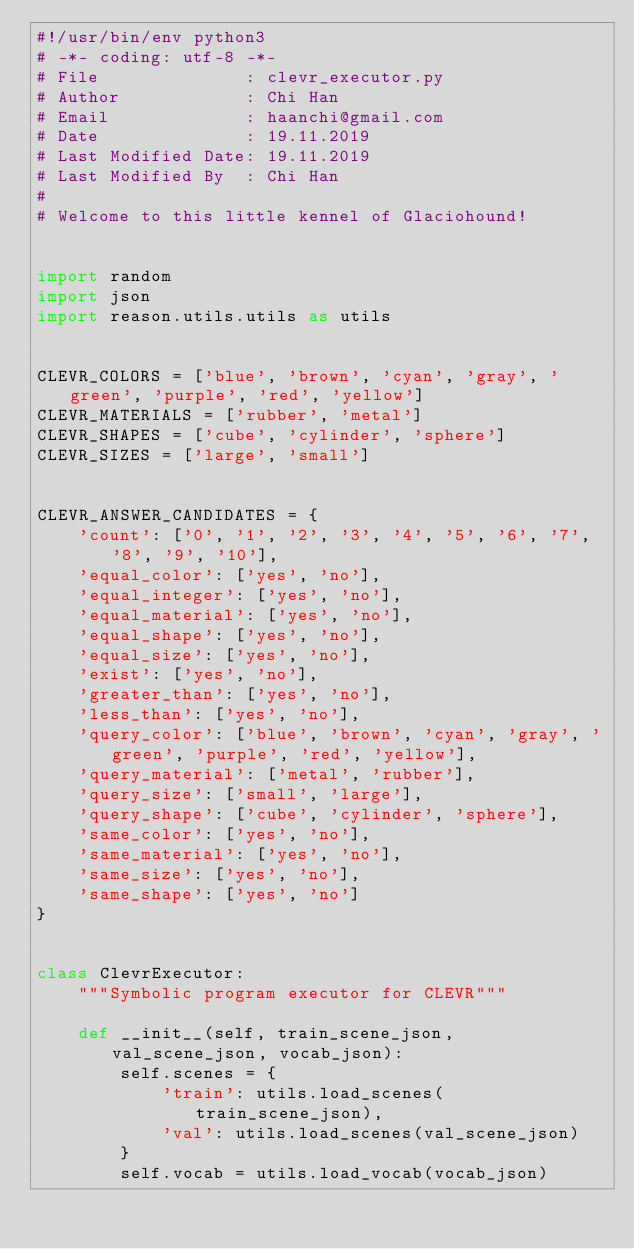<code> <loc_0><loc_0><loc_500><loc_500><_Python_>#!/usr/bin/env python3
# -*- coding: utf-8 -*-
# File              : clevr_executor.py
# Author            : Chi Han
# Email             : haanchi@gmail.com
# Date              : 19.11.2019
# Last Modified Date: 19.11.2019
# Last Modified By  : Chi Han
#
# Welcome to this little kennel of Glaciohound!


import random
import json
import reason.utils.utils as utils


CLEVR_COLORS = ['blue', 'brown', 'cyan', 'gray', 'green', 'purple', 'red', 'yellow']
CLEVR_MATERIALS = ['rubber', 'metal']
CLEVR_SHAPES = ['cube', 'cylinder', 'sphere']
CLEVR_SIZES = ['large', 'small']


CLEVR_ANSWER_CANDIDATES = {
    'count': ['0', '1', '2', '3', '4', '5', '6', '7', '8', '9', '10'],
    'equal_color': ['yes', 'no'],
    'equal_integer': ['yes', 'no'],
    'equal_material': ['yes', 'no'],
    'equal_shape': ['yes', 'no'],
    'equal_size': ['yes', 'no'],
    'exist': ['yes', 'no'],
    'greater_than': ['yes', 'no'],
    'less_than': ['yes', 'no'],
    'query_color': ['blue', 'brown', 'cyan', 'gray', 'green', 'purple', 'red', 'yellow'],
    'query_material': ['metal', 'rubber'],
    'query_size': ['small', 'large'],
    'query_shape': ['cube', 'cylinder', 'sphere'],
    'same_color': ['yes', 'no'],
    'same_material': ['yes', 'no'],
    'same_size': ['yes', 'no'],
    'same_shape': ['yes', 'no']
}


class ClevrExecutor:
    """Symbolic program executor for CLEVR"""

    def __init__(self, train_scene_json, val_scene_json, vocab_json):
        self.scenes = {
            'train': utils.load_scenes(train_scene_json),
            'val': utils.load_scenes(val_scene_json)
        }
        self.vocab = utils.load_vocab(vocab_json)</code> 